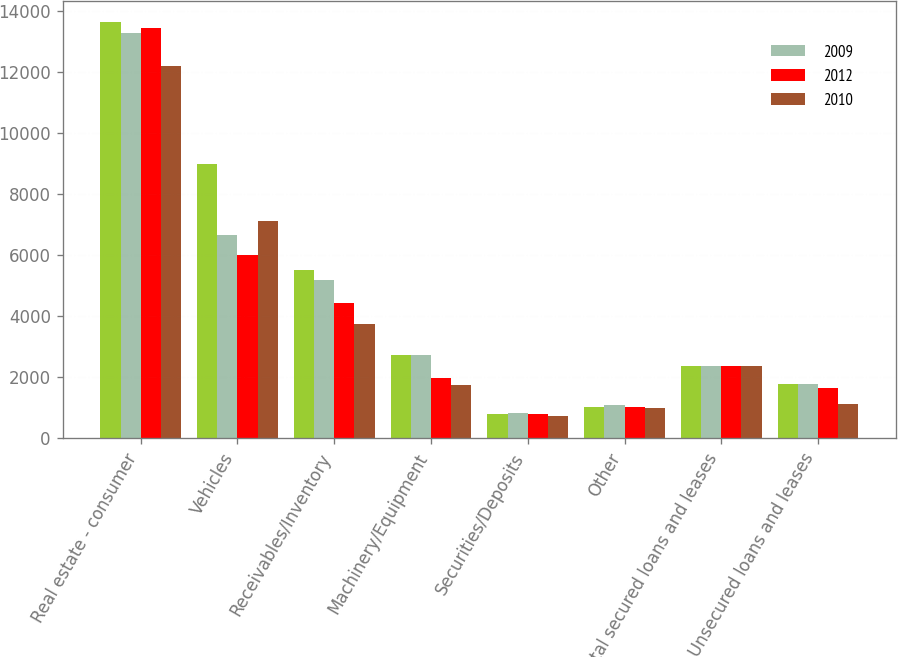Convert chart. <chart><loc_0><loc_0><loc_500><loc_500><stacked_bar_chart><ecel><fcel>Real estate - consumer<fcel>Vehicles<fcel>Receivables/Inventory<fcel>Machinery/Equipment<fcel>Securities/Deposits<fcel>Other<fcel>Total secured loans and leases<fcel>Unsecured loans and leases<nl><fcel>nan<fcel>13657<fcel>8989<fcel>5534<fcel>2738<fcel>786<fcel>1016<fcel>2366<fcel>1778<nl><fcel>2009<fcel>13305<fcel>6659<fcel>5178<fcel>2749<fcel>826<fcel>1090<fcel>2366<fcel>1793<nl><fcel>2012<fcel>13444<fcel>6021<fcel>4450<fcel>1994<fcel>800<fcel>1018<fcel>2366<fcel>1640<nl><fcel>2010<fcel>12214<fcel>7134<fcel>3763<fcel>1766<fcel>734<fcel>990<fcel>2366<fcel>1117<nl></chart> 